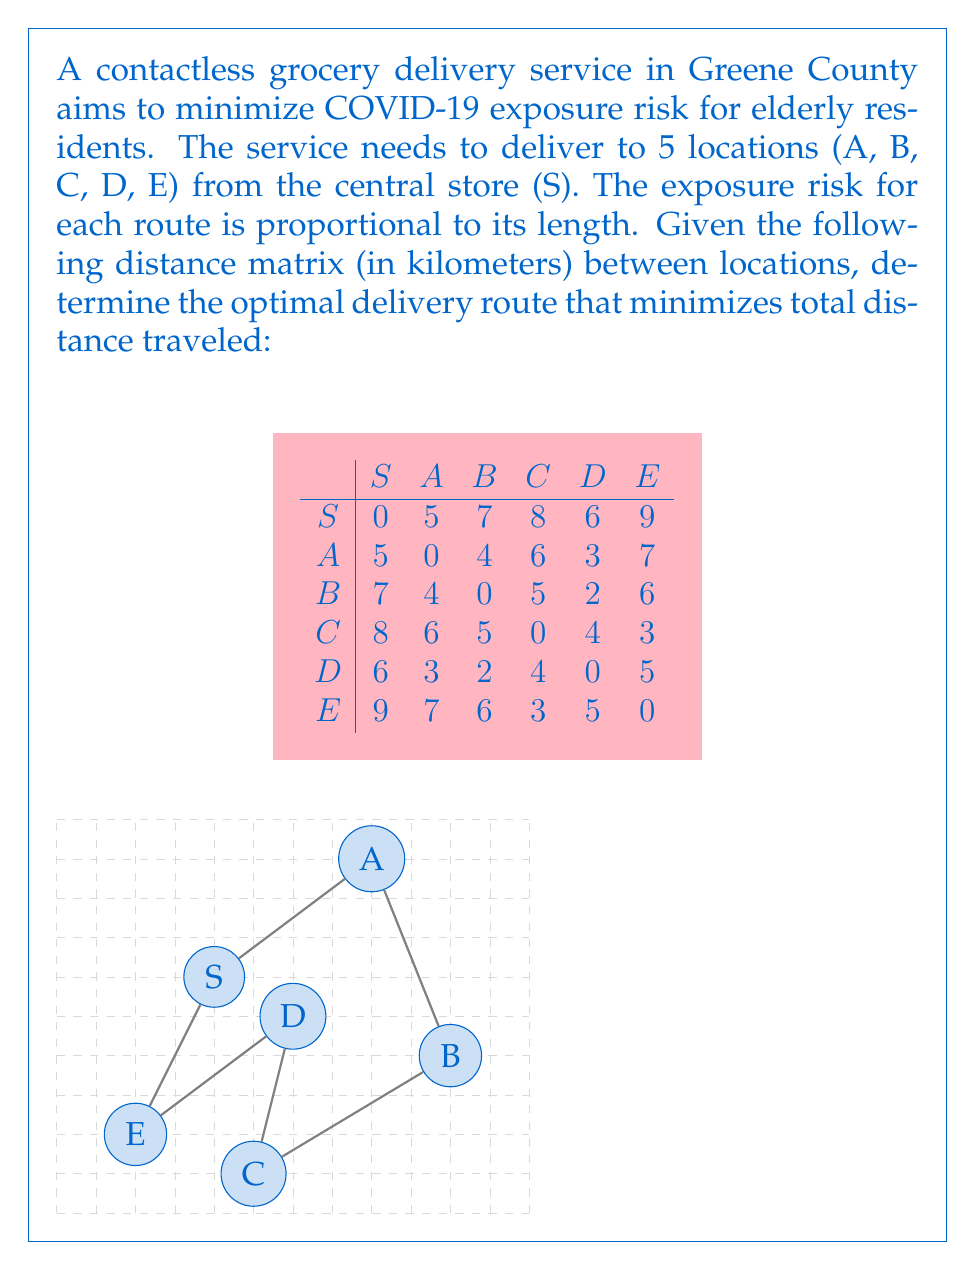Can you answer this question? To solve this problem, we'll use the nearest neighbor algorithm, which is a heuristic method for solving the Traveling Salesman Problem. While it doesn't guarantee the optimal solution, it provides a good approximation and is simple to implement.

Step 1: Start at the store (S).

Step 2: Find the nearest unvisited location:
- S to A: 5 km
- S to B: 7 km
- S to C: 8 km
- S to D: 6 km
- S to E: 9 km
The nearest is A (5 km).

Step 3: Move to A and repeat:
- A to B: 4 km
- A to C: 6 km
- A to D: 3 km
- A to E: 7 km
The nearest is D (3 km).

Step 4: Move to D and repeat:
- D to B: 2 km
- D to C: 4 km
- D to E: 5 km
The nearest is B (2 km).

Step 5: Move to B and repeat:
- B to C: 5 km
- B to E: 6 km
The nearest is C (5 km).

Step 6: Move to C, with only E remaining:
- C to E: 3 km

Step 7: Return to S from E:
- E to S: 9 km

The total route is: S → A → D → B → C → E → S

Step 8: Calculate total distance:
$$ \text{Total distance} = 5 + 3 + 2 + 5 + 3 + 9 = 27 \text{ km} $$
Answer: S → A → D → B → C → E → S, 27 km 